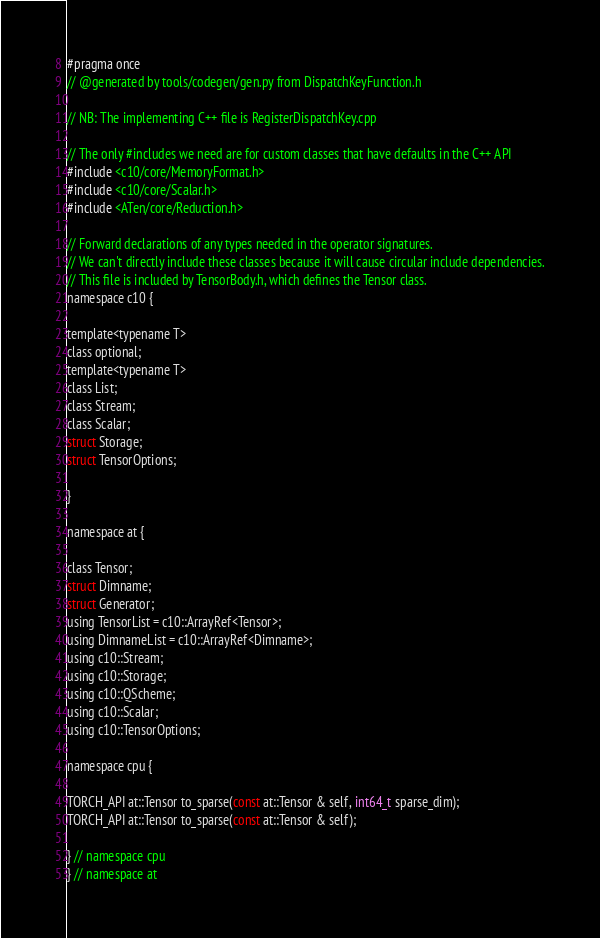<code> <loc_0><loc_0><loc_500><loc_500><_C_>#pragma once
// @generated by tools/codegen/gen.py from DispatchKeyFunction.h

// NB: The implementing C++ file is RegisterDispatchKey.cpp

// The only #includes we need are for custom classes that have defaults in the C++ API
#include <c10/core/MemoryFormat.h>
#include <c10/core/Scalar.h>
#include <ATen/core/Reduction.h>

// Forward declarations of any types needed in the operator signatures.
// We can't directly include these classes because it will cause circular include dependencies.
// This file is included by TensorBody.h, which defines the Tensor class.
namespace c10 {

template<typename T>
class optional;
template<typename T>
class List;
class Stream;
class Scalar;
struct Storage;
struct TensorOptions;

}

namespace at {

class Tensor;
struct Dimname;
struct Generator;
using TensorList = c10::ArrayRef<Tensor>;
using DimnameList = c10::ArrayRef<Dimname>;
using c10::Stream;
using c10::Storage;
using c10::QScheme;
using c10::Scalar;
using c10::TensorOptions;

namespace cpu {

TORCH_API at::Tensor to_sparse(const at::Tensor & self, int64_t sparse_dim);
TORCH_API at::Tensor to_sparse(const at::Tensor & self);

} // namespace cpu
} // namespace at
</code> 